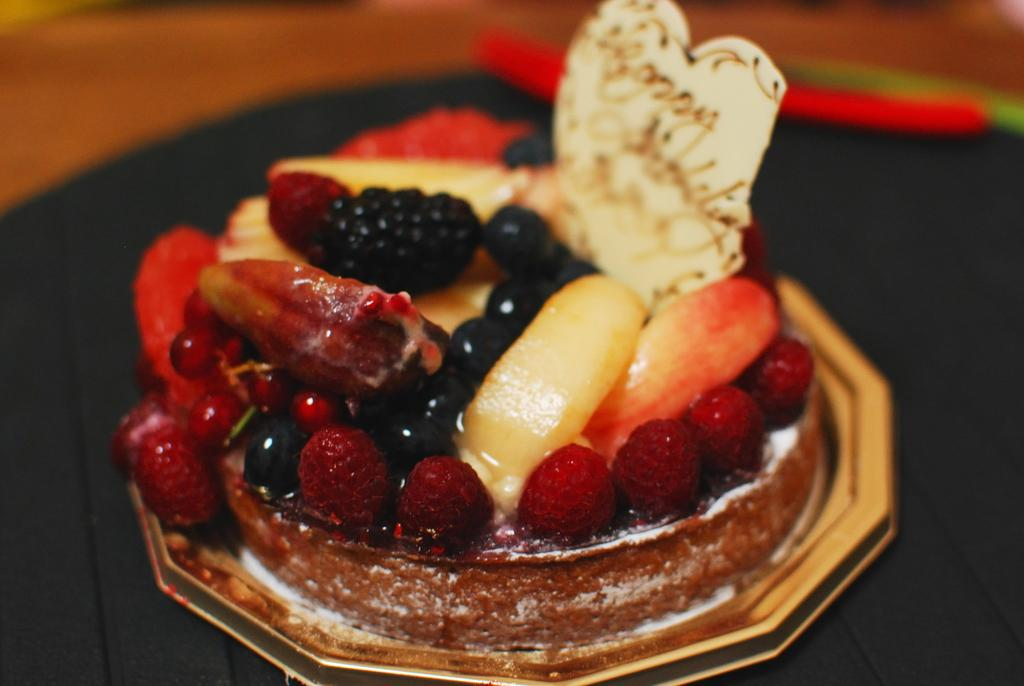What is the main subject of the picture? The main subject of the picture is a cake. What decorations are on the cake? The cake has strawberries and other fruits on it. Can you tell me how many snakes are wrapped around the cake in the image? There are no snakes present in the image; the cake has fruits on it. What type of eggs are used as a topping on the cake in the image? There are no eggs present on the cake in the image; it has fruits as decorations. 